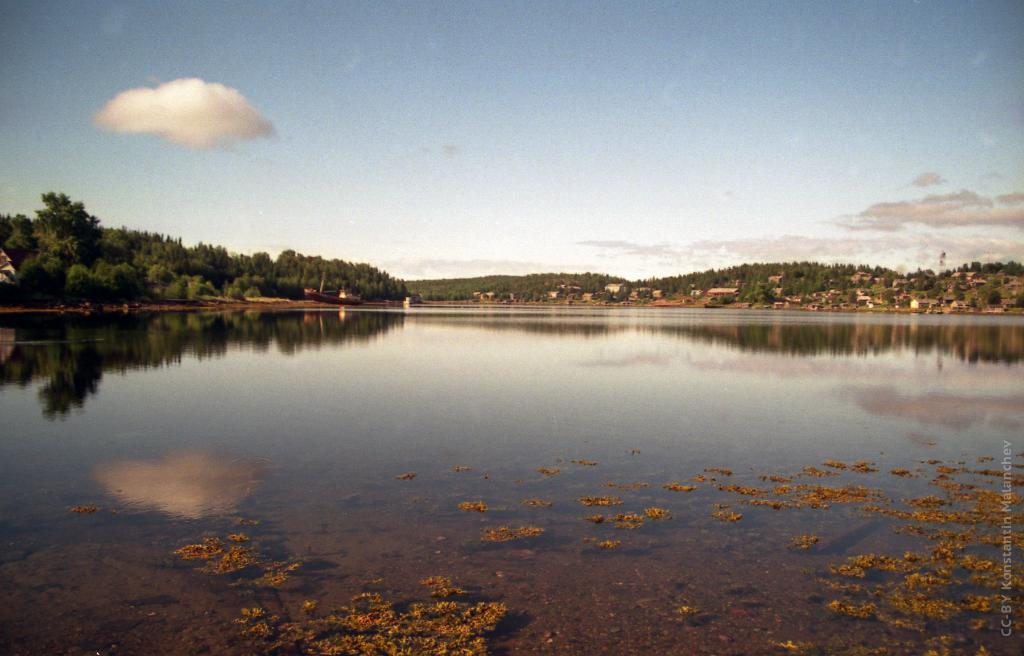What is visible in the image? Water is visible in the image. What can be seen in the background of the image? There are trees and the sky visible in the background of the image. Are there any clouds in the background of the image? Yes, there are clouds in the background of the image. Where is the grandmother sitting with her sack in the image? There is no grandmother or sack present in the image. What does the father do in the image? There is no father present in the image. 